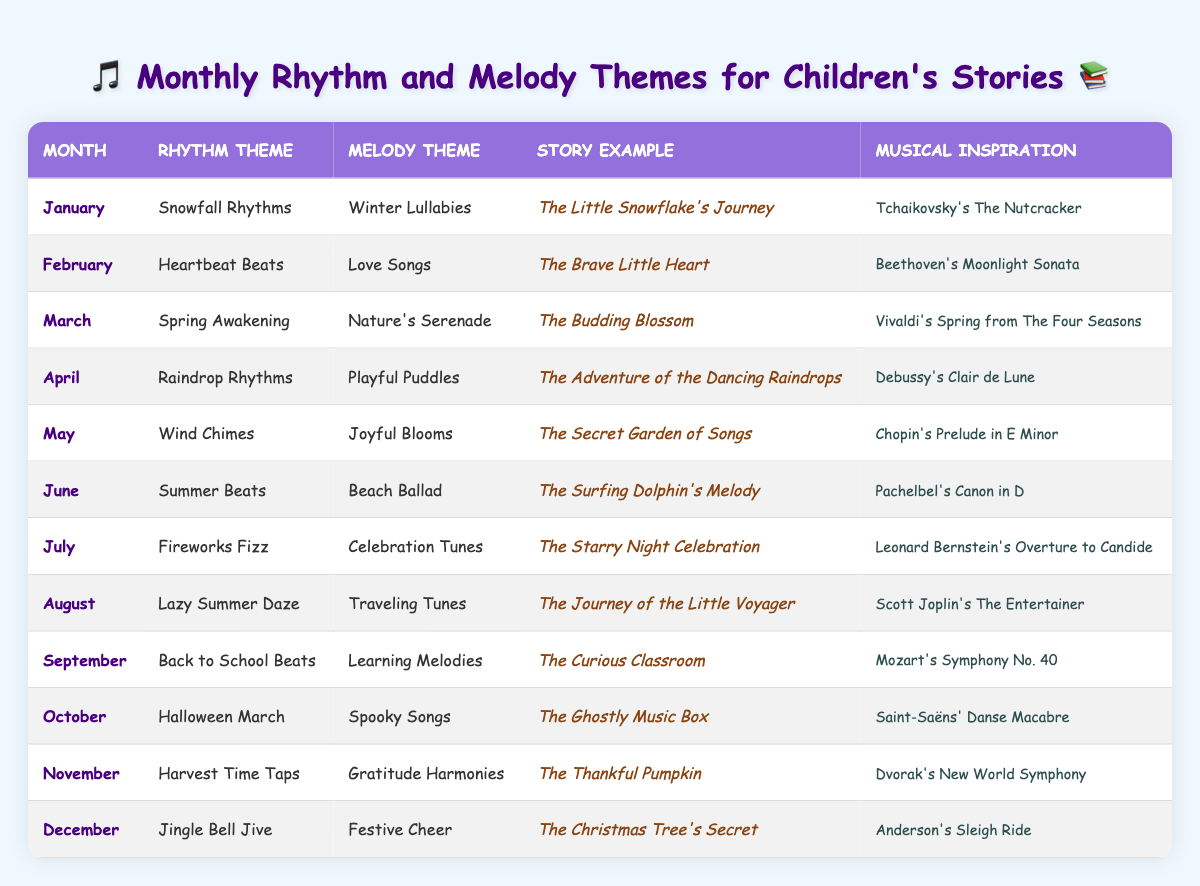What is the rhythm theme for March? Referring to the table, under the month of March, the rhythm theme listed is "Spring Awakening."
Answer: Spring Awakening What story represents the melody theme "Summer Beats"? Looking at the row for June, the story example corresponding to the melody theme "Summer Beats" is "The Surfing Dolphin's Melody."
Answer: The Surfing Dolphin's Melody Which month's theme is inspired by Mozart? The month of September features the melody theme "Learning Melodies," inspired by Mozart's "Symphony No. 40."
Answer: September Does the table include a story for October? Yes, the story for October, which is associated with the theme "Halloween March," is "The Ghostly Music Box."
Answer: Yes What is the melody theme for January, and what story does it relate to? The melody theme for January is "Winter Lullabies," and the related story is "The Little Snowflake's Journey."
Answer: Winter Lullabies; The Little Snowflake's Journey In which month do the themes revolve around "Gratitude Harmonies"? The month that features "Gratitude Harmonies" as the melody theme is November.
Answer: November Compare the rhythm themes of February and December. February has "Heartbeat Beats" and December has "Jingle Bell Jive," indicating that February focuses on more emotional themes while December is festive.
Answer: February: Heartbeat Beats; December: Jingle Bell Jive What month has the theme of "Raindrop Rhythms"? The table indicates that "Raindrop Rhythms" is the theme for April.
Answer: April Which month has both a rhythm and melody theme focusing on celebration? July features the rhythm theme "Fireworks Fizz" and the melody theme "Celebration Tunes," both centered around celebration.
Answer: July What is the average number of letters in the melody themes for each month? Counting the letters in the melody themes: 16 (Winter Lullabies) + 9 (Love Songs) + 14 (Nature's Serenade) + 13 (Playful Puddles) + 12 (Joyful Blooms) + 11 (Beach Ballad) + 16 (Celebration Tunes) + 15 (Traveling Tunes) + 16 (Learning Melodies) + 12 (Spooky Songs) + 18 (Gratitude Harmonies) + 11 (Festive Cheer) =  165 total letters; there are 12 themes, so the average is 165/12 = 13.75.
Answer: 13.75 What story is related to the musical inspiration "Debussy's Clair de Lune"? The story associated with the inspiration "Debussy's Clair de Lune" is "The Adventure of the Dancing Raindrops," from April's theme.
Answer: The Adventure of the Dancing Raindrops Is there a rhythmic theme that focuses on nature's elements in spring? Yes, the rhythm theme "Spring Awakening" fits this description for March.
Answer: Yes 